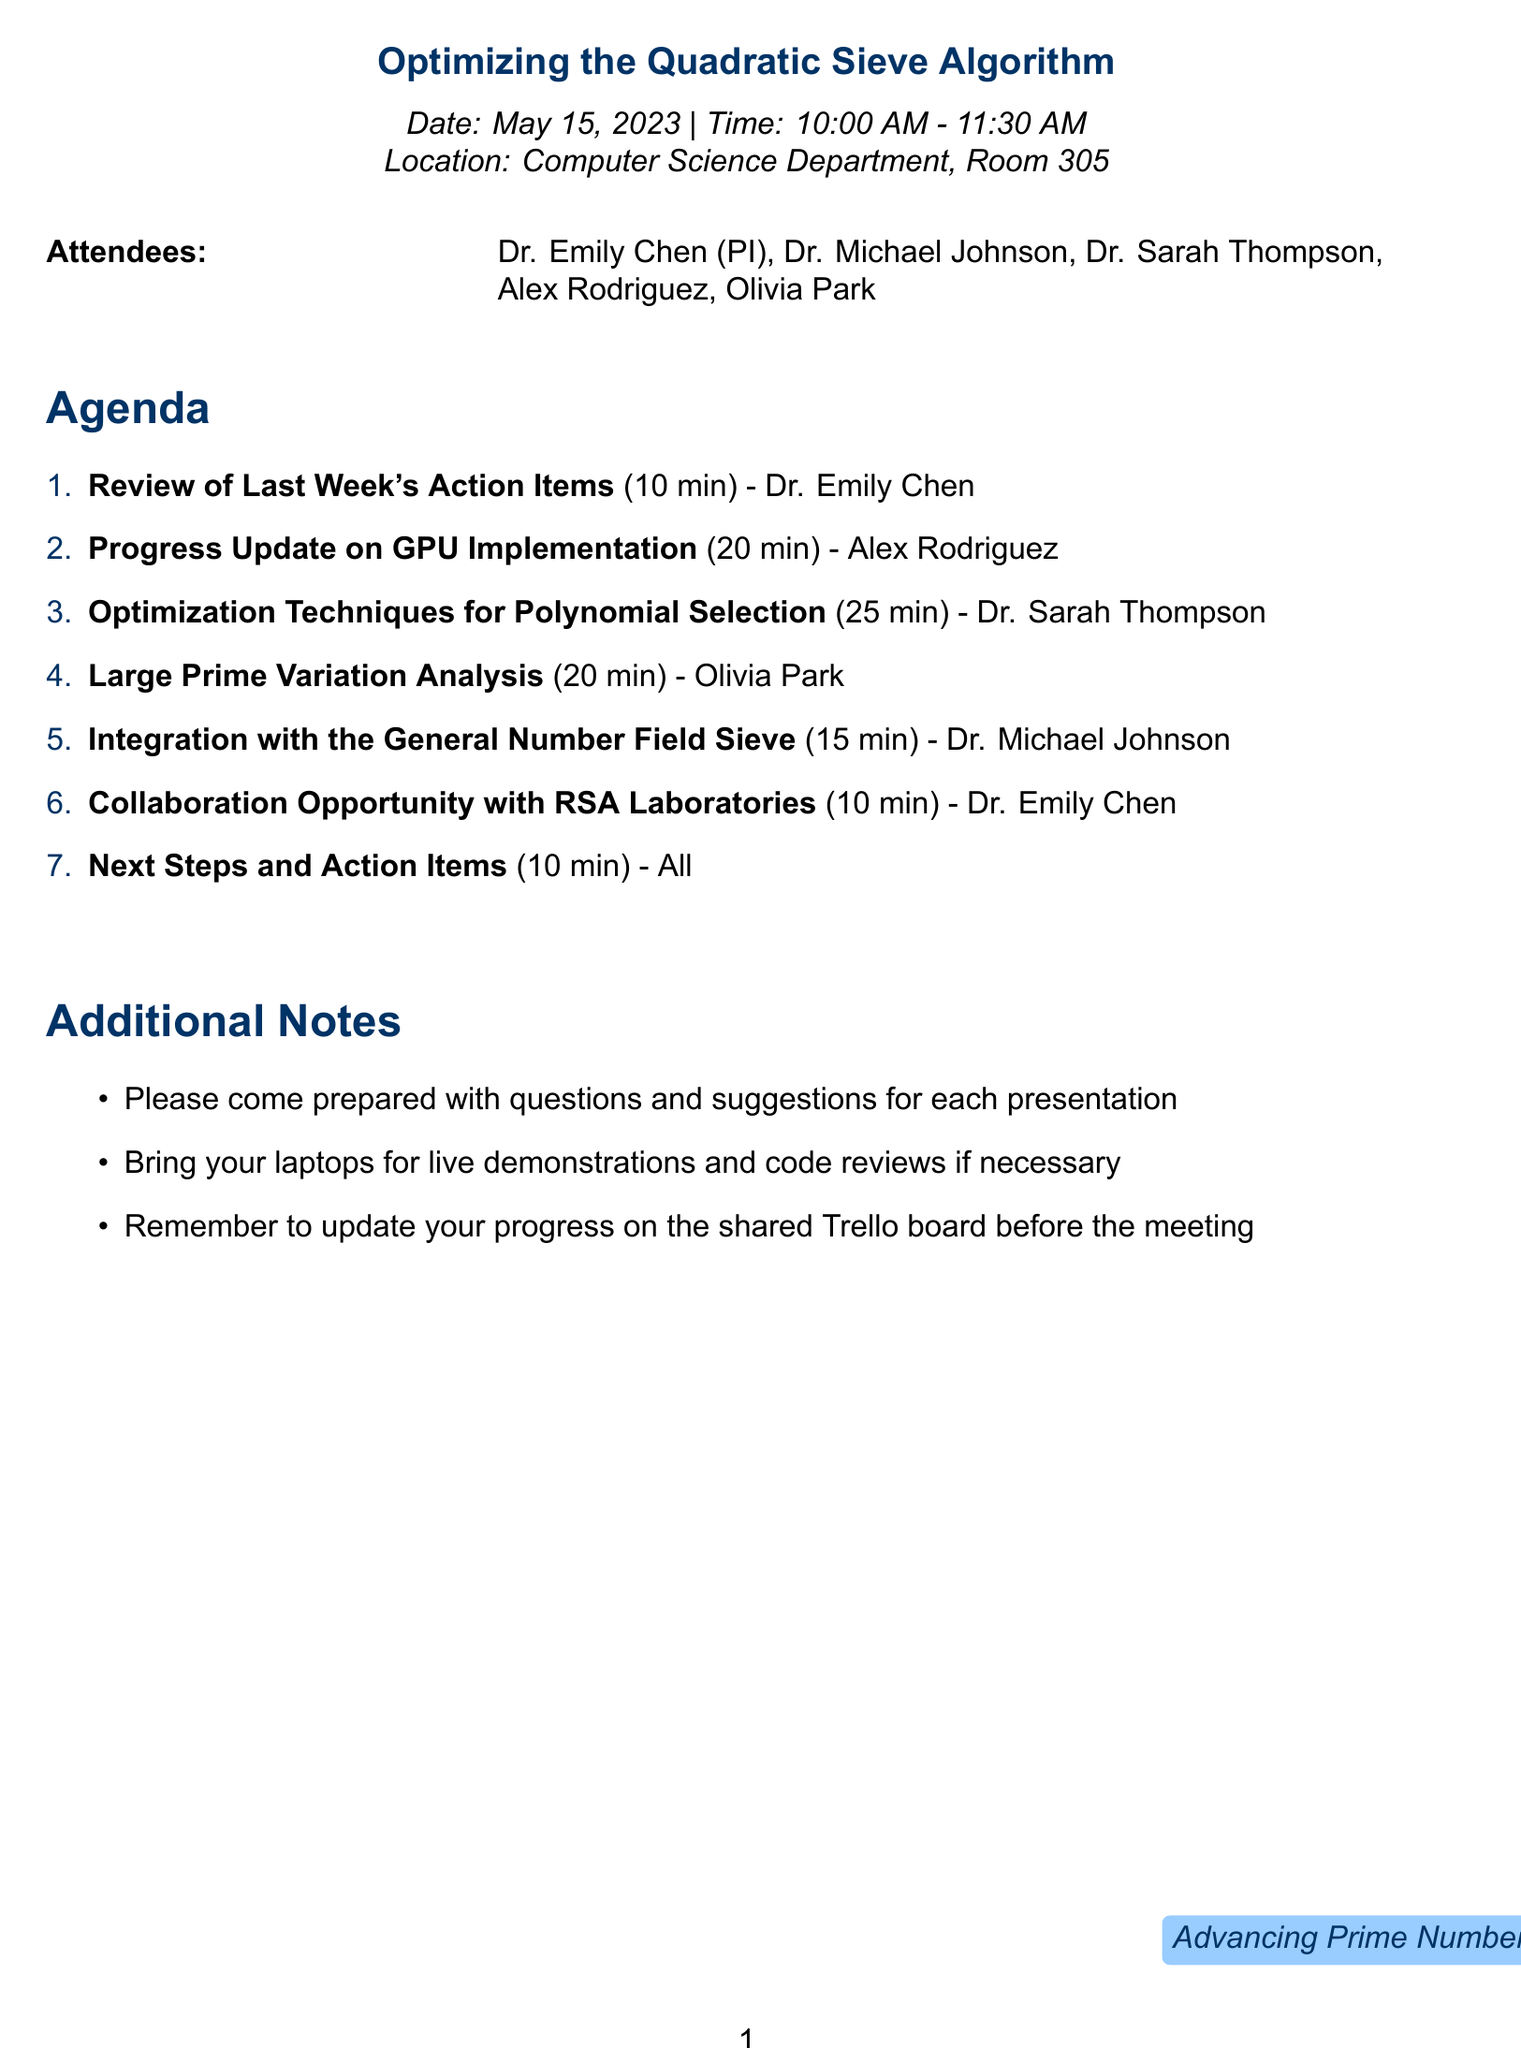What is the date of the meeting? The date of the meeting is explicitly stated in the document.
Answer: May 15, 2023 Who is the presenter for the "Large Prime Variation Analysis"? The document lists presenters for each agenda item, including their names.
Answer: Olivia Park What is the duration of the "Progress Update on GPU Implementation"? The duration for each agenda item is specified, including this one.
Answer: 20 minutes Which room will the meeting take place in? The location of the meeting is provided in the document.
Answer: Room 305 What is one of the additional notes for the attendees? The document includes additional notes that provide instructions for attendees.
Answer: Bring your laptops for live demonstrations and code reviews if necessary Which researcher is leading the discussion on Optimization Techniques for Polynomial Selection? The document mentions the presenter for each agenda item and their roles.
Answer: Dr. Sarah Thompson How many minutes are allocated for the "Next Steps and Action Items"? The time allocated for each agenda item is detailed in the document.
Answer: 10 minutes Who is the principal investigator? The attendees section identifies the principal investigator among other attendees.
Answer: Dr. Emily Chen What will be discussed for 15 minutes regarding other algorithms? The agenda specifies discussion topics including comparisons with other algorithms.
Answer: Integration with the General Number Field Sieve 